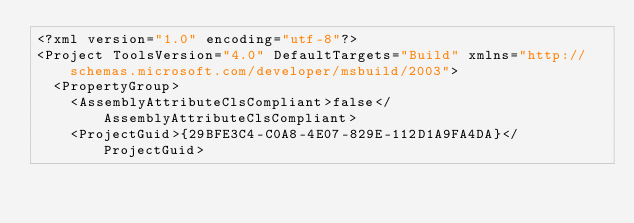<code> <loc_0><loc_0><loc_500><loc_500><_XML_><?xml version="1.0" encoding="utf-8"?>
<Project ToolsVersion="4.0" DefaultTargets="Build" xmlns="http://schemas.microsoft.com/developer/msbuild/2003">
  <PropertyGroup>
    <AssemblyAttributeClsCompliant>false</AssemblyAttributeClsCompliant>
    <ProjectGuid>{29BFE3C4-C0A8-4E07-829E-112D1A9FA4DA}</ProjectGuid></code> 